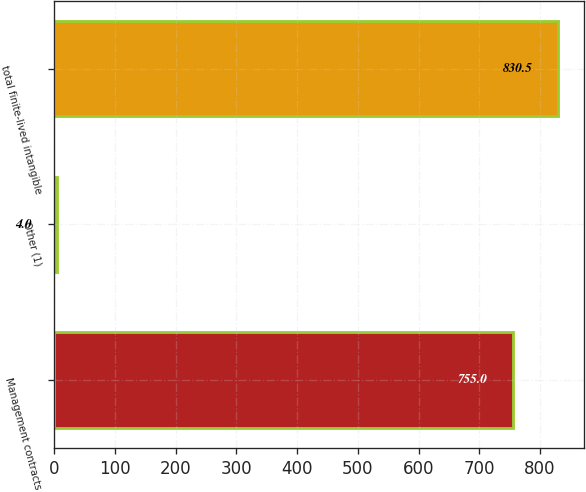Convert chart to OTSL. <chart><loc_0><loc_0><loc_500><loc_500><bar_chart><fcel>Management contracts<fcel>Other (1)<fcel>total finite-lived intangible<nl><fcel>755<fcel>4<fcel>830.5<nl></chart> 